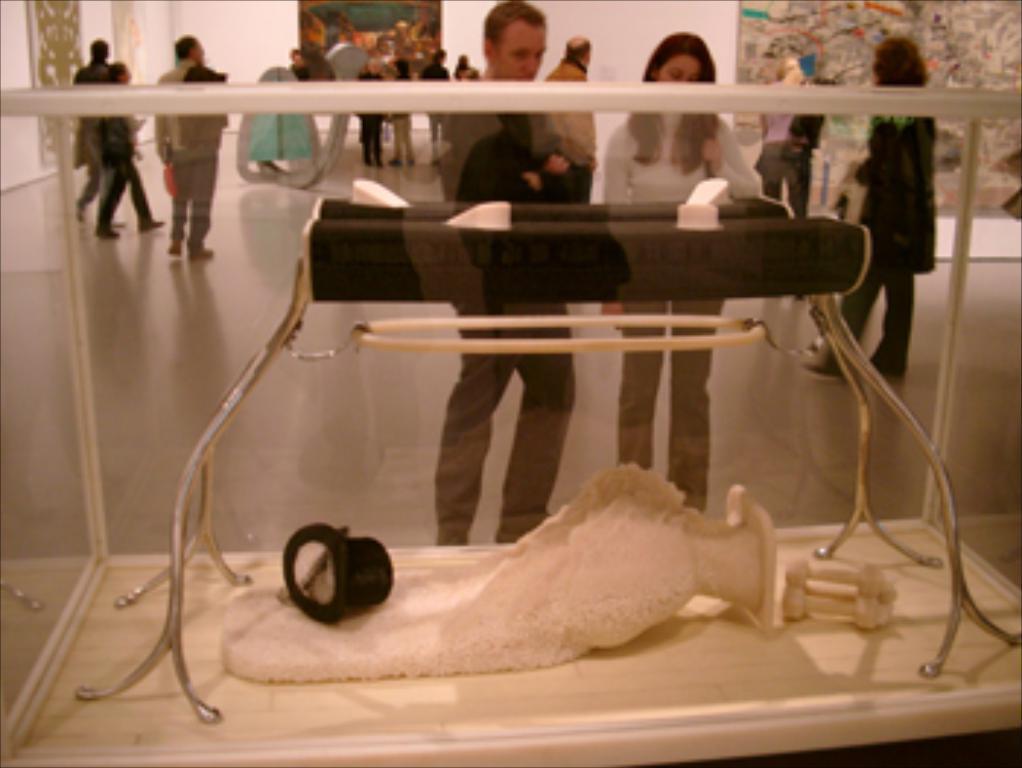Can you describe this image briefly? In this image in the foreground there is one glass box in that box there is one stool, and some items. In the background there are some people who are standing and watching that glass box, and also there are some people who are walking and there are some paintings. 